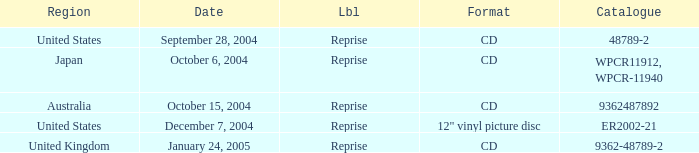Name the date that is a cd September 28, 2004, October 6, 2004, October 15, 2004, January 24, 2005. 